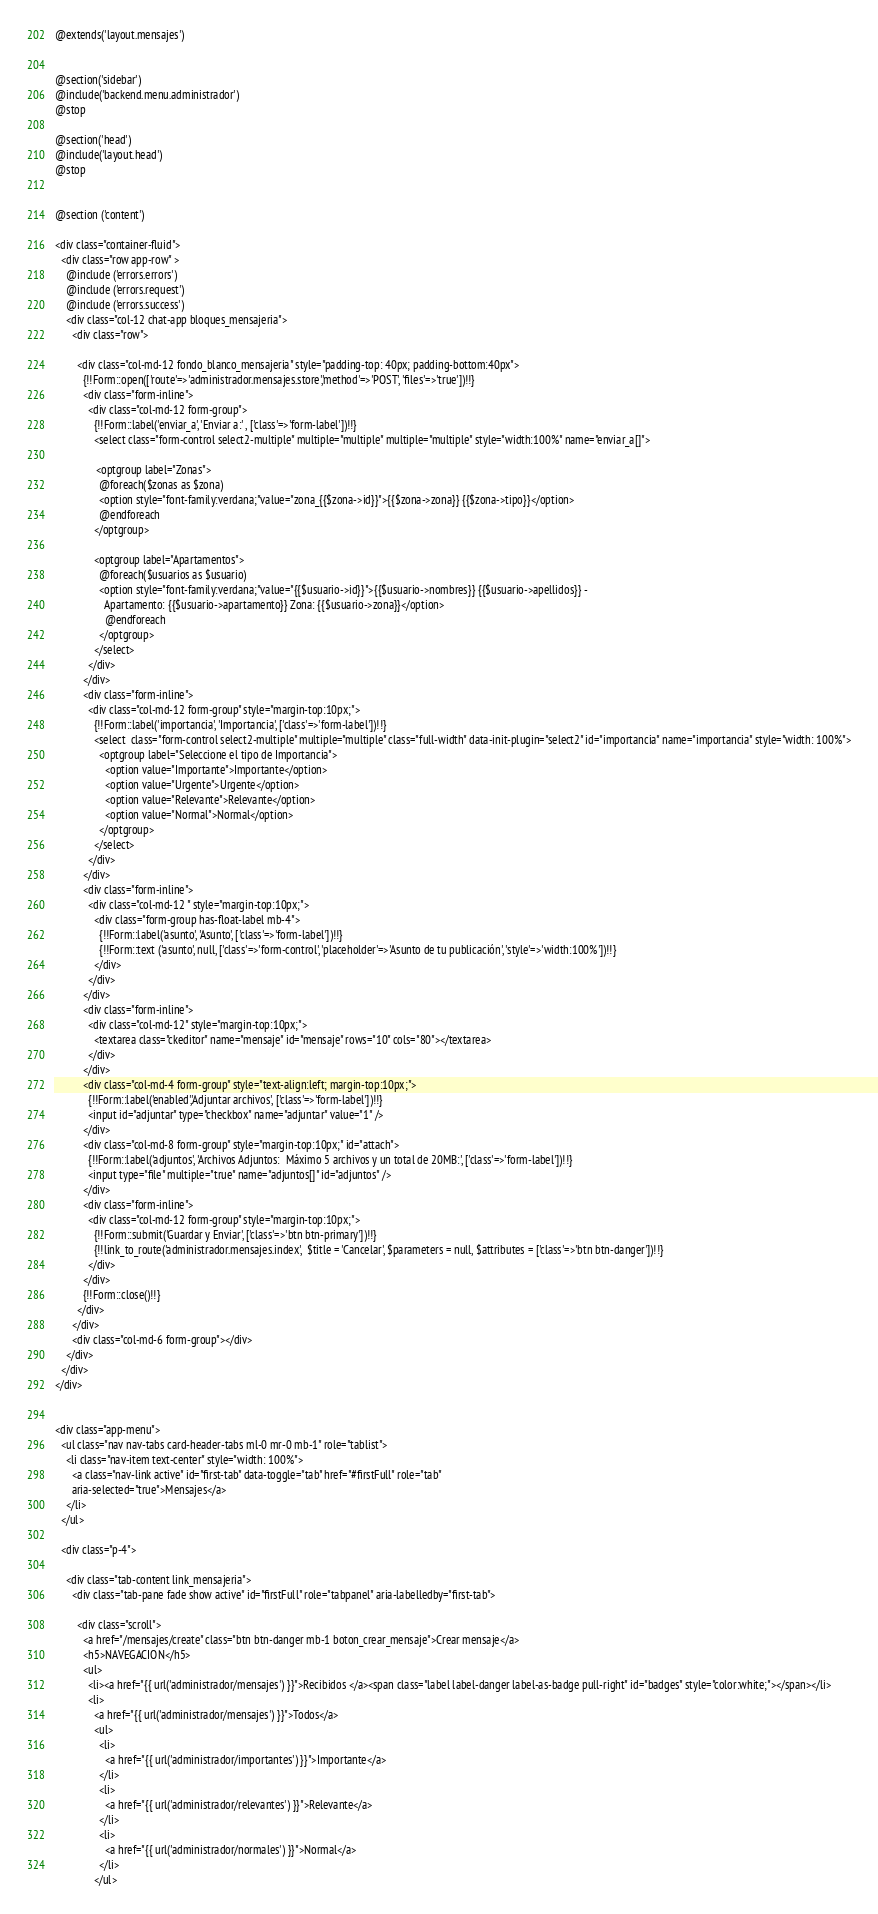Convert code to text. <code><loc_0><loc_0><loc_500><loc_500><_PHP_>@extends('layout.mensajes')


@section('sidebar')
@include('backend.menu.administrador')
@stop

@section('head')
@include('layout.head')
@stop


@section ('content')

<div class="container-fluid">
  <div class="row app-row" >
    @include ('errors.errors')
    @include ('errors.request')
    @include ('errors.success')
    <div class="col-12 chat-app bloques_mensajeria">
      <div class="row">

        <div class="col-md-12 fondo_blanco_mensajeria" style="padding-top: 40px; padding-bottom:40px">
          {!!Form::open(['route'=>'administrador.mensajes.store','method'=>'POST', 'files'=>'true'])!!}
          <div class="form-inline">
            <div class="col-md-12 form-group">
              {!!Form::label('enviar_a', 'Enviar a:' , ['class'=>'form-label'])!!}
              <select class="form-control select2-multiple" multiple="multiple" multiple="multiple" style="width:100%" name="enviar_a[]">

               <optgroup label="Zonas">                              
                @foreach($zonas as $zona)
                <option style="font-family:verdana;"value="zona_{{$zona->id}}">{{$zona->zona}} {{$zona->tipo}}</option>
                @endforeach
              </optgroup>

              <optgroup label="Apartamentos">                              
                @foreach($usuarios as $usuario)
                <option style="font-family:verdana;"value="{{$usuario->id}}">{{$usuario->nombres}} {{$usuario->apellidos}} -
                  Apartamento: {{$usuario->apartamento}} Zona: {{$usuario->zona}}</option>
                  @endforeach
                </optgroup>
              </select>
            </div>
          </div>
          <div class="form-inline">
            <div class="col-md-12 form-group" style="margin-top:10px;">
              {!!Form::label('importancia', 'Importancia', ['class'=>'form-label'])!!}
              <select  class="form-control select2-multiple" multiple="multiple" class="full-width" data-init-plugin="select2" id="importancia" name="importancia" style="width: 100%">
                <optgroup label="Seleccione el tipo de Importancia">
                  <option value="Importante">Importante</option>
                  <option value="Urgente">Urgente</option>
                  <option value="Relevante">Relevante</option>
                  <option value="Normal">Normal</option>
                </optgroup>
              </select>
            </div>
          </div>
          <div class="form-inline">
            <div class="col-md-12 " style="margin-top:10px;">
              <div class="form-group has-float-label mb-4">
                {!!Form::label('asunto', 'Asunto', ['class'=>'form-label'])!!}
                {!!Form::text ('asunto', null, ['class'=>'form-control', 'placeholder'=>'Asunto de tu publicación', 'style'=>'width:100%'])!!}
              </div>
            </div>
          </div>
          <div class="form-inline">
            <div class="col-md-12" style="margin-top:10px;">
              <textarea class="ckeditor" name="mensaje" id="mensaje" rows="10" cols="80"></textarea>
            </div>
          </div>
          <div class="col-md-4 form-group" style="text-align:left; margin-top:10px;">
            {!!Form::label('enabled','Adjuntar archivos', ['class'=>'form-label'])!!}
            <input id="adjuntar" type="checkbox" name="adjuntar" value="1" />
          </div>
          <div class="col-md-8 form-group" style="margin-top:10px;" id="attach">
            {!!Form::label('adjuntos', 'Archivos Adjuntos:  Máximo 5 archivos y un total de 20MB:', ['class'=>'form-label'])!!}
            <input type="file" multiple="true" name="adjuntos[]" id="adjuntos" /> 
          </div>
          <div class="form-inline">
            <div class="col-md-12 form-group" style="margin-top:10px;">   
              {!!Form::submit('Guardar y Enviar', ['class'=>'btn btn-primary'])!!}
              {!!link_to_route('administrador.mensajes.index',  $title = 'Cancelar', $parameters = null, $attributes = ['class'=>'btn btn-danger'])!!}
            </div>  
          </div> 
          {!!Form::close()!!} 
        </div>
      </div>
      <div class="col-md-6 form-group"></div>
    </div>
  </div>
</div>


<div class="app-menu">
  <ul class="nav nav-tabs card-header-tabs ml-0 mr-0 mb-1" role="tablist">
    <li class="nav-item text-center" style="width: 100%">
      <a class="nav-link active" id="first-tab" data-toggle="tab" href="#firstFull" role="tab"
      aria-selected="true">Mensajes</a>
    </li>
  </ul>

  <div class="p-4">

    <div class="tab-content link_mensajeria">
      <div class="tab-pane fade show active" id="firstFull" role="tabpanel" aria-labelledby="first-tab">

        <div class="scroll">
          <a href="/mensajes/create" class="btn btn-danger mb-1 boton_crear_mensaje">Crear mensaje</a>
          <h5>NAVEGACION</h5>
          <ul>
            <li><a href="{{ url('administrador/mensajes') }}">Recibidos </a><span class="label label-danger label-as-badge pull-right" id="badges" style="color:white;"></span></li>
            <li>
              <a href="{{ url('administrador/mensajes') }}">Todos</a>
              <ul>
                <li>
                  <a href="{{ url('administrador/importantes') }}">Importante</a>
                </li>
                <li>
                  <a href="{{ url('administrador/relevantes') }}">Relevante</a>
                </li>
                <li>
                  <a href="{{ url('administrador/normales') }}">Normal</a>
                </li>
              </ul></code> 